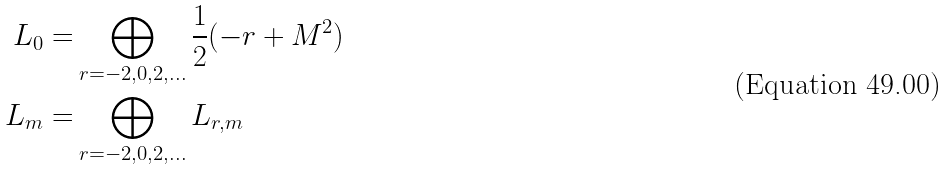Convert formula to latex. <formula><loc_0><loc_0><loc_500><loc_500>L _ { 0 } = & \bigoplus _ { r = - 2 , 0 , 2 , \dots } \frac { 1 } { 2 } ( - r + M ^ { 2 } ) \\ L _ { m } = & \bigoplus _ { r = - 2 , 0 , 2 , \dots } L _ { r , m } \\</formula> 